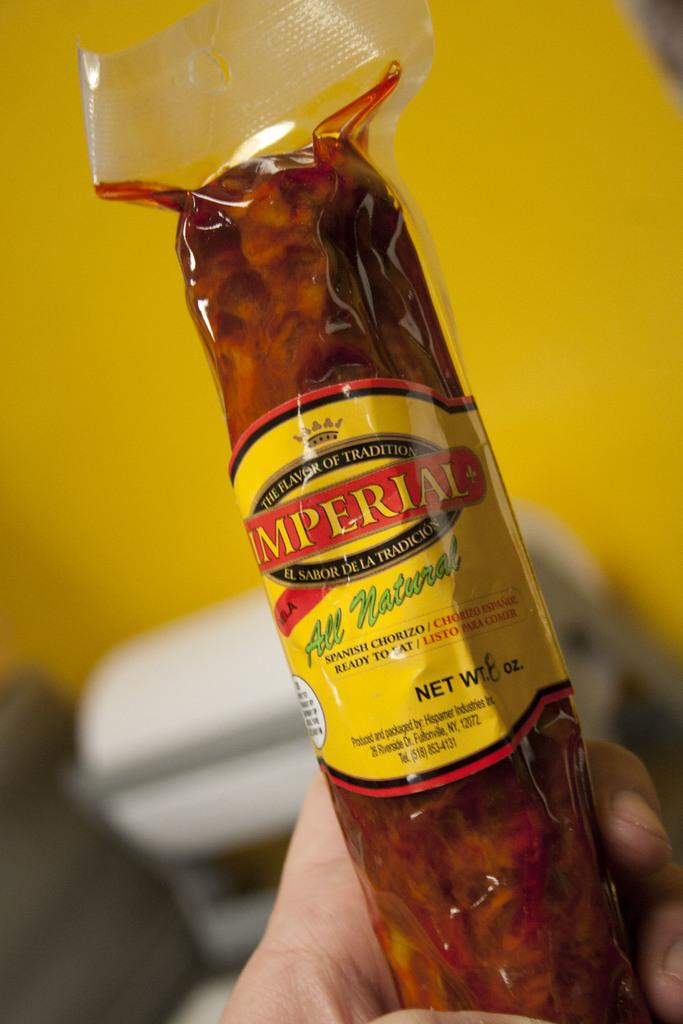Provide a one-sentence caption for the provided image. A stick of Imperial brand chorizo sausage being held in a hand. 